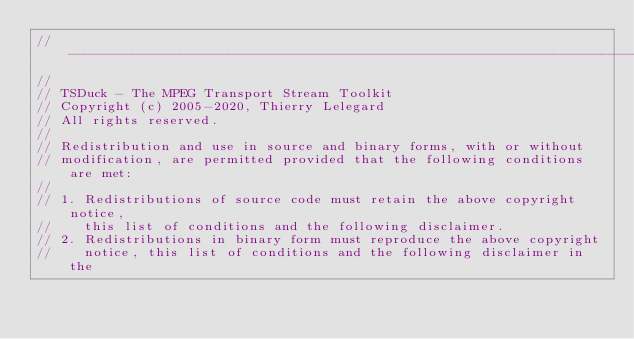Convert code to text. <code><loc_0><loc_0><loc_500><loc_500><_C++_>//----------------------------------------------------------------------------
//
// TSDuck - The MPEG Transport Stream Toolkit
// Copyright (c) 2005-2020, Thierry Lelegard
// All rights reserved.
//
// Redistribution and use in source and binary forms, with or without
// modification, are permitted provided that the following conditions are met:
//
// 1. Redistributions of source code must retain the above copyright notice,
//    this list of conditions and the following disclaimer.
// 2. Redistributions in binary form must reproduce the above copyright
//    notice, this list of conditions and the following disclaimer in the</code> 